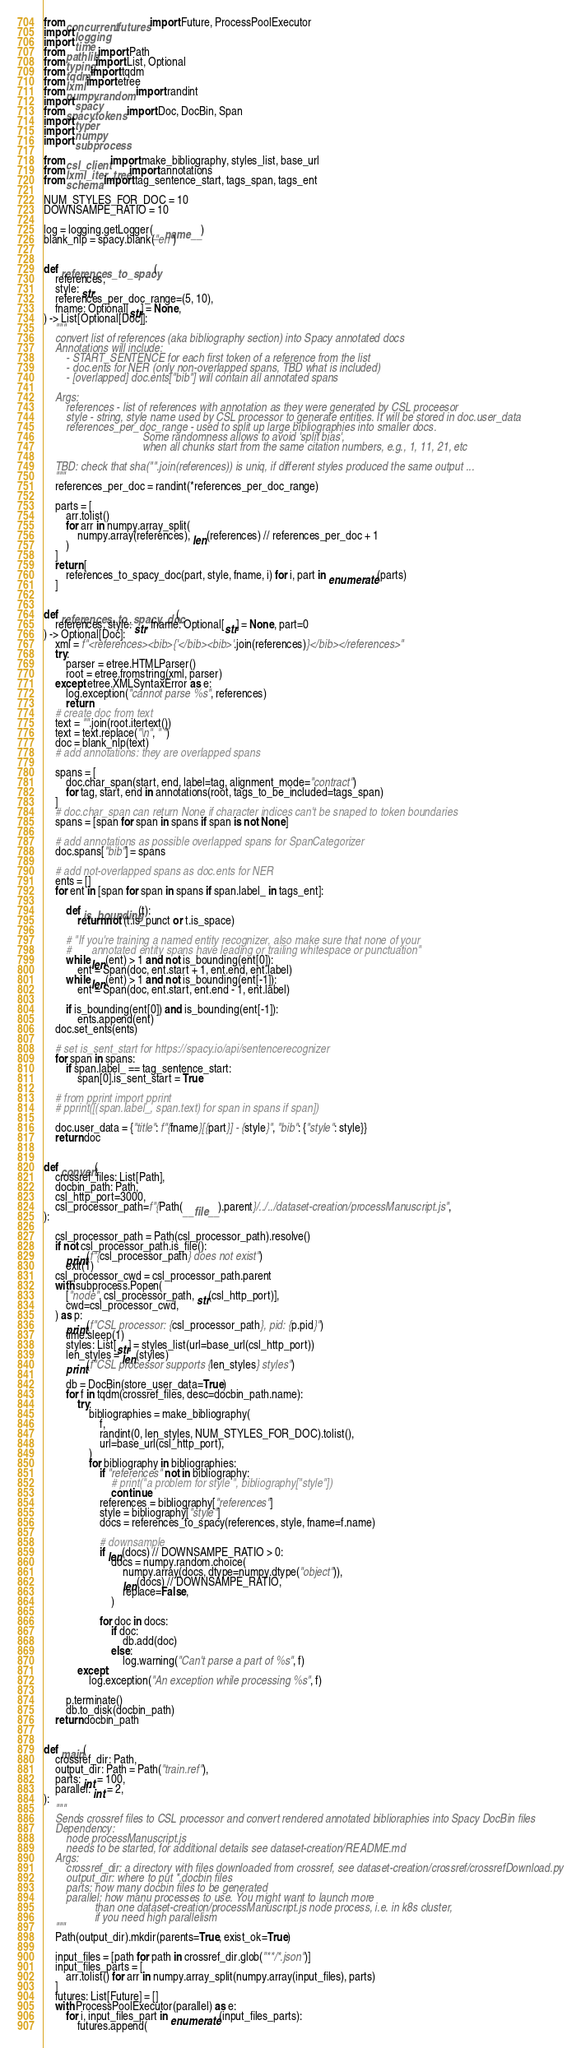Convert code to text. <code><loc_0><loc_0><loc_500><loc_500><_Python_>from concurrent.futures import Future, ProcessPoolExecutor
import logging
import time
from pathlib import Path
from typing import List, Optional
from tqdm import tqdm
from lxml import etree
from numpy.random import randint
import spacy
from spacy.tokens import Doc, DocBin, Span
import typer
import numpy
import subprocess

from csl_client import make_bibliography, styles_list, base_url
from lxml_iter_tree import annotations
from schema import tag_sentence_start, tags_span, tags_ent

NUM_STYLES_FOR_DOC = 10
DOWNSAMPE_RATIO = 10

log = logging.getLogger(__name__)
blank_nlp = spacy.blank("en")


def references_to_spacy(
    references,
    style: str,
    references_per_doc_range=(5, 10),
    fname: Optional[str] = None,
) -> List[Optional[Doc]]:
    """
    convert list of references (aka bibliography section) into Spacy annotated docs
    Annotations will include:
        - START_SENTENCE for each first token of a reference from the list
        - doc.ents for NER (only non-overlapped spans, TBD what is included)
        - [overlapped] doc.ents["bib"] will contain all annotated spans

    Args:
        references - list of references with annotation as they were generated by CSL proceesor
        style - string, style name used by CSL processor to generate entities. It will be stored in doc.user_data
        references_per_doc_range - used to split up large bibliographies into smaller docs.
                                   Some randomness allows to avoid 'split bias',
                                   when all chunks start from the same citation numbers, e.g., 1, 11, 21, etc

    TBD: check that sha("".join(references)) is uniq, if different styles produced the same output ...
    """
    references_per_doc = randint(*references_per_doc_range)

    parts = [
        arr.tolist()
        for arr in numpy.array_split(
            numpy.array(references), len(references) // references_per_doc + 1
        )
    ]
    return [
        references_to_spacy_doc(part, style, fname, i) for i, part in enumerate(parts)
    ]


def references_to_spacy_doc(
    references, style: str, fname: Optional[str] = None, part=0
) -> Optional[Doc]:
    xml = f"<references><bib>{'</bib><bib>'.join(references)}</bib></references>"
    try:
        parser = etree.HTMLParser()
        root = etree.fromstring(xml, parser)
    except etree.XMLSyntaxError as e:
        log.exception("cannot parse %s", references)
        return
    # create doc from text
    text = "".join(root.itertext())
    text = text.replace("\n", " ")
    doc = blank_nlp(text)
    # add annotations: they are overlapped spans

    spans = [
        doc.char_span(start, end, label=tag, alignment_mode="contract")
        for tag, start, end in annotations(root, tags_to_be_included=tags_span)
    ]
    # doc.char_span can return None if character indices can't be snaped to token boundaries
    spans = [span for span in spans if span is not None]

    # add annotations as possible overlapped spans for SpanCategorizer
    doc.spans["bib"] = spans

    # add not-overlapped spans as doc.ents for NER
    ents = []
    for ent in [span for span in spans if span.label_ in tags_ent]:

        def is_bounding(t):
            return not (t.is_punct or t.is_space)

        # "If you're training a named entity recognizer, also make sure that none of your
        #       annotated entity spans have leading or trailing whitespace or punctuation"
        while len(ent) > 1 and not is_bounding(ent[0]):
            ent = Span(doc, ent.start + 1, ent.end, ent.label)
        while len(ent) > 1 and not is_bounding(ent[-1]):
            ent = Span(doc, ent.start, ent.end - 1, ent.label)

        if is_bounding(ent[0]) and is_bounding(ent[-1]):
            ents.append(ent)
    doc.set_ents(ents)

    # set is_sent_start for https://spacy.io/api/sentencerecognizer
    for span in spans:
        if span.label_ == tag_sentence_start:
            span[0].is_sent_start = True

    # from pprint import pprint
    # pprint([(span.label_, span.text) for span in spans if span])

    doc.user_data = {"title": f"{fname}[{part}] - {style}", "bib": {"style": style}}
    return doc


def convert(
    crossref_files: List[Path],
    docbin_path: Path,
    csl_http_port=3000,
    csl_processor_path=f"{Path(__file__).parent}/../../dataset-creation/processManuscript.js",
):

    csl_processor_path = Path(csl_processor_path).resolve()
    if not csl_processor_path.is_file():
        print(f"{csl_processor_path} does not exist")
        exit(1)
    csl_processor_cwd = csl_processor_path.parent
    with subprocess.Popen(
        ["node", csl_processor_path, str(csl_http_port)],
        cwd=csl_processor_cwd,
    ) as p:
        print(f"CSL processor: {csl_processor_path}, pid: {p.pid}")
        time.sleep(1)
        styles: List[str] = styles_list(url=base_url(csl_http_port))
        len_styles = len(styles)
        print(f"CSL processor supports {len_styles} styles")

        db = DocBin(store_user_data=True)
        for f in tqdm(crossref_files, desc=docbin_path.name):
            try:
                bibliographies = make_bibliography(
                    f,
                    randint(0, len_styles, NUM_STYLES_FOR_DOC).tolist(),
                    url=base_url(csl_http_port),
                )
                for bibliography in bibliographies:
                    if "references" not in bibliography:
                        # print("a problem for style ", bibliography["style"])
                        continue
                    references = bibliography["references"]
                    style = bibliography["style"]
                    docs = references_to_spacy(references, style, fname=f.name)

                    # downsample
                    if len(docs) // DOWNSAMPE_RATIO > 0:
                        docs = numpy.random.choice(
                            numpy.array(docs, dtype=numpy.dtype("object")),
                            len(docs) // DOWNSAMPE_RATIO,
                            replace=False,
                        )

                    for doc in docs:
                        if doc:
                            db.add(doc)
                        else:
                            log.warning("Can't parse a part of %s", f)
            except:
                log.exception("An exception while processing %s", f)

        p.terminate()
        db.to_disk(docbin_path)
    return docbin_path


def main(
    crossref_dir: Path,
    output_dir: Path = Path("train.ref"),
    parts: int = 100,
    parallel: int = 2,
):
    """
    Sends crossref files to CSL processor and convert rendered annotated biblioraphies into Spacy DocBin files
    Dependency:
        node processManuscript.js
        needs to be started, for additional details see dataset-creation/README.md
    Args:
        crossref_dir: a directory with files downloaded from crossref, see dataset-creation/crossref/crossrefDownload.py
        output_dir: where to put *.docbin files
        parts: how many docbin files to be generated
        parallel: how manu processes to use. You might want to launch more
                  than one dataset-creation/processManuscript.js node process, i.e. in k8s cluster,
                  if you need high parallelism
    """
    Path(output_dir).mkdir(parents=True, exist_ok=True)

    input_files = [path for path in crossref_dir.glob("**/*.json")]
    input_files_parts = [
        arr.tolist() for arr in numpy.array_split(numpy.array(input_files), parts)
    ]
    futures: List[Future] = []
    with ProcessPoolExecutor(parallel) as e:
        for i, input_files_part in enumerate(input_files_parts):
            futures.append(</code> 